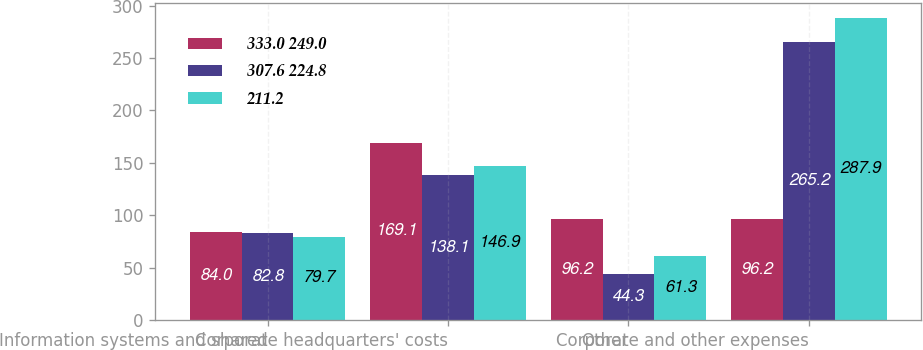Convert chart to OTSL. <chart><loc_0><loc_0><loc_500><loc_500><stacked_bar_chart><ecel><fcel>Information systems and shared<fcel>Corporate headquarters' costs<fcel>Other<fcel>Corporate and other expenses<nl><fcel>333.0 249.0<fcel>84<fcel>169.1<fcel>96.2<fcel>96.2<nl><fcel>307.6 224.8<fcel>82.8<fcel>138.1<fcel>44.3<fcel>265.2<nl><fcel>211.2<fcel>79.7<fcel>146.9<fcel>61.3<fcel>287.9<nl></chart> 